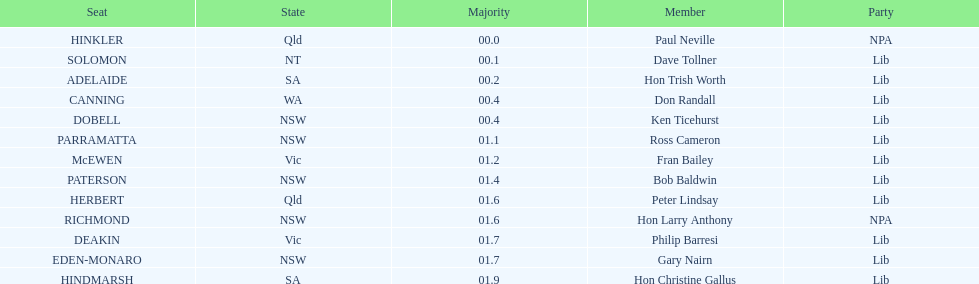What is the aggregate of seats? 13. 